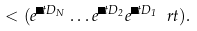<formula> <loc_0><loc_0><loc_500><loc_500>< ( e ^ { \Delta t D _ { N } } \dots e ^ { \Delta t D _ { 2 } } e ^ { \Delta t D _ { 1 } } \ r t ) .</formula> 